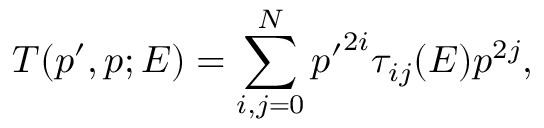<formula> <loc_0><loc_0><loc_500><loc_500>T ( p ^ { \prime } , p ; E ) = \sum _ { i , j = 0 } ^ { N } { p ^ { \prime } } ^ { 2 i } \tau _ { i j } ( E ) p ^ { 2 j } ,</formula> 